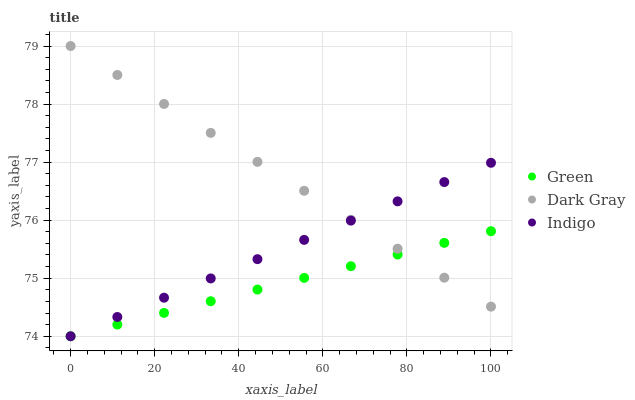Does Green have the minimum area under the curve?
Answer yes or no. Yes. Does Dark Gray have the maximum area under the curve?
Answer yes or no. Yes. Does Indigo have the minimum area under the curve?
Answer yes or no. No. Does Indigo have the maximum area under the curve?
Answer yes or no. No. Is Indigo the smoothest?
Answer yes or no. Yes. Is Green the roughest?
Answer yes or no. Yes. Is Green the smoothest?
Answer yes or no. No. Is Indigo the roughest?
Answer yes or no. No. Does Indigo have the lowest value?
Answer yes or no. Yes. Does Dark Gray have the highest value?
Answer yes or no. Yes. Does Indigo have the highest value?
Answer yes or no. No. Does Dark Gray intersect Green?
Answer yes or no. Yes. Is Dark Gray less than Green?
Answer yes or no. No. Is Dark Gray greater than Green?
Answer yes or no. No. 